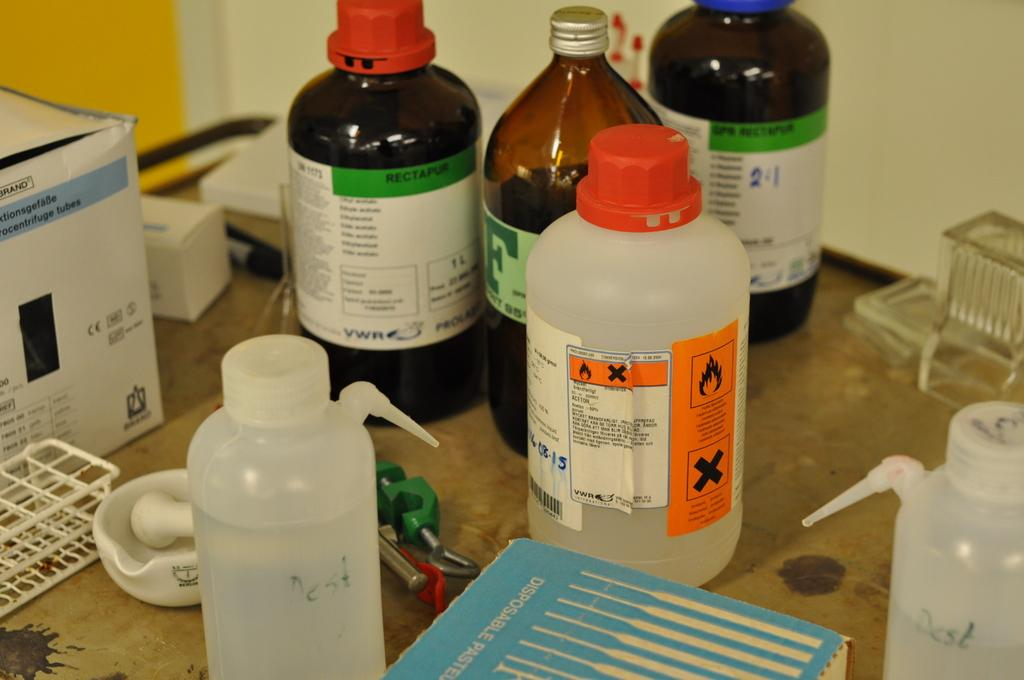<image>
Share a concise interpretation of the image provided. Bottle with a green label that says "Rectapur" near the top. 